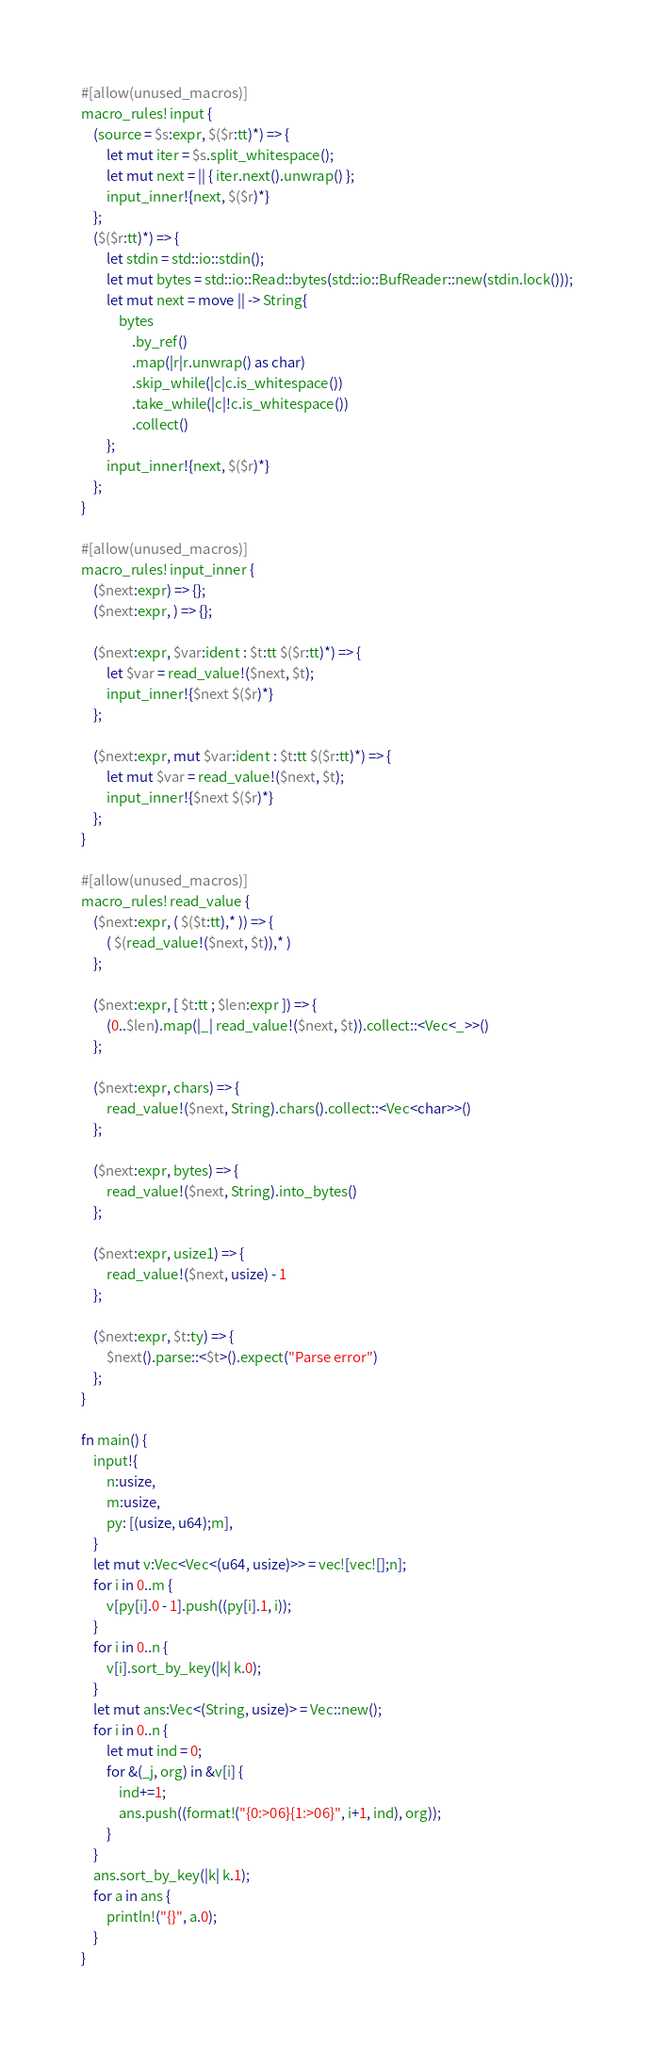<code> <loc_0><loc_0><loc_500><loc_500><_Rust_>#[allow(unused_macros)]
macro_rules! input {
    (source = $s:expr, $($r:tt)*) => {
        let mut iter = $s.split_whitespace();
        let mut next = || { iter.next().unwrap() };
        input_inner!{next, $($r)*}
    };
    ($($r:tt)*) => {
        let stdin = std::io::stdin();
        let mut bytes = std::io::Read::bytes(std::io::BufReader::new(stdin.lock()));
        let mut next = move || -> String{
            bytes
                .by_ref()
                .map(|r|r.unwrap() as char)
                .skip_while(|c|c.is_whitespace())
                .take_while(|c|!c.is_whitespace())
                .collect()
        };
        input_inner!{next, $($r)*}
    };
}

#[allow(unused_macros)]
macro_rules! input_inner {
    ($next:expr) => {};
    ($next:expr, ) => {};

    ($next:expr, $var:ident : $t:tt $($r:tt)*) => {
        let $var = read_value!($next, $t);
        input_inner!{$next $($r)*}
    };

    ($next:expr, mut $var:ident : $t:tt $($r:tt)*) => {
        let mut $var = read_value!($next, $t);
        input_inner!{$next $($r)*}
    };
}

#[allow(unused_macros)]
macro_rules! read_value {
    ($next:expr, ( $($t:tt),* )) => {
        ( $(read_value!($next, $t)),* )
    };

    ($next:expr, [ $t:tt ; $len:expr ]) => {
        (0..$len).map(|_| read_value!($next, $t)).collect::<Vec<_>>()
    };

    ($next:expr, chars) => {
        read_value!($next, String).chars().collect::<Vec<char>>()
    };

    ($next:expr, bytes) => {
        read_value!($next, String).into_bytes()
    };

    ($next:expr, usize1) => {
        read_value!($next, usize) - 1
    };

    ($next:expr, $t:ty) => {
        $next().parse::<$t>().expect("Parse error")
    };
}

fn main() {
    input!{
        n:usize,
        m:usize,
        py: [(usize, u64);m],
    }
    let mut v:Vec<Vec<(u64, usize)>> = vec![vec![];n];
    for i in 0..m {
        v[py[i].0 - 1].push((py[i].1, i));
    }
    for i in 0..n {
        v[i].sort_by_key(|k| k.0);
    }
    let mut ans:Vec<(String, usize)> = Vec::new();
    for i in 0..n {
        let mut ind = 0;
        for &(_j, org) in &v[i] {
            ind+=1;
            ans.push((format!("{0:>06}{1:>06}", i+1, ind), org));
        }
    }
    ans.sort_by_key(|k| k.1);
    for a in ans {
        println!("{}", a.0);
    }
}</code> 